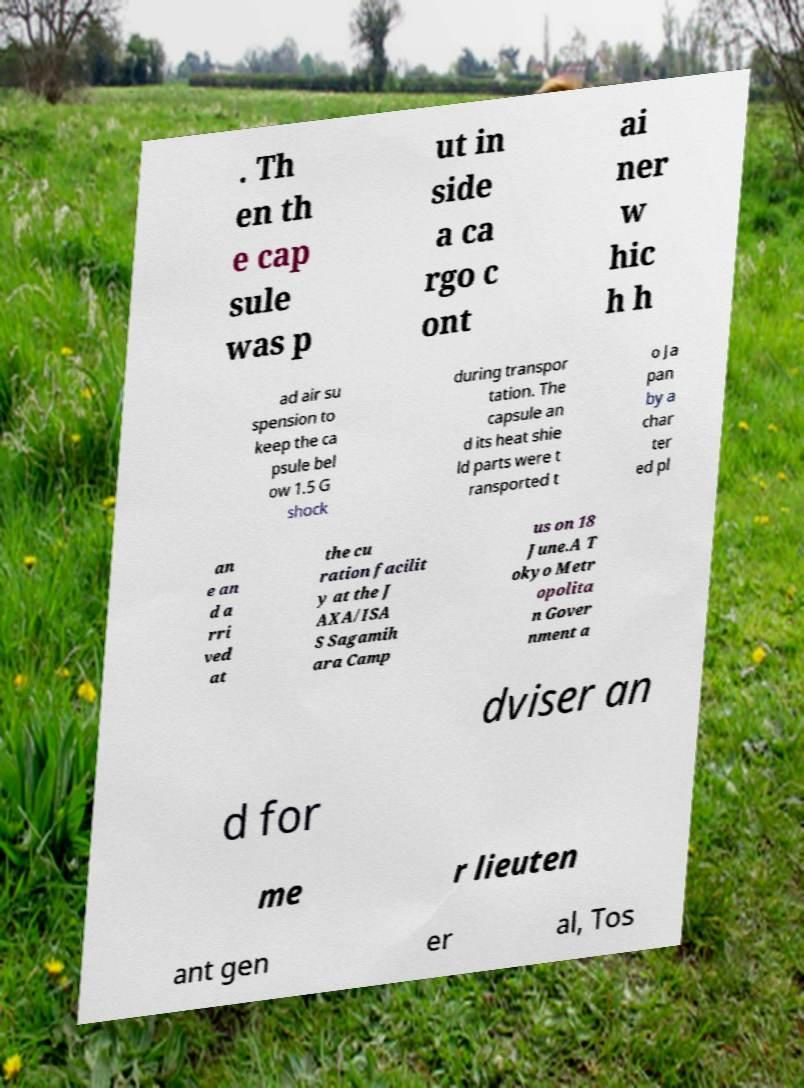For documentation purposes, I need the text within this image transcribed. Could you provide that? . Th en th e cap sule was p ut in side a ca rgo c ont ai ner w hic h h ad air su spension to keep the ca psule bel ow 1.5 G shock during transpor tation. The capsule an d its heat shie ld parts were t ransported t o Ja pan by a char ter ed pl an e an d a rri ved at the cu ration facilit y at the J AXA/ISA S Sagamih ara Camp us on 18 June.A T okyo Metr opolita n Gover nment a dviser an d for me r lieuten ant gen er al, Tos 